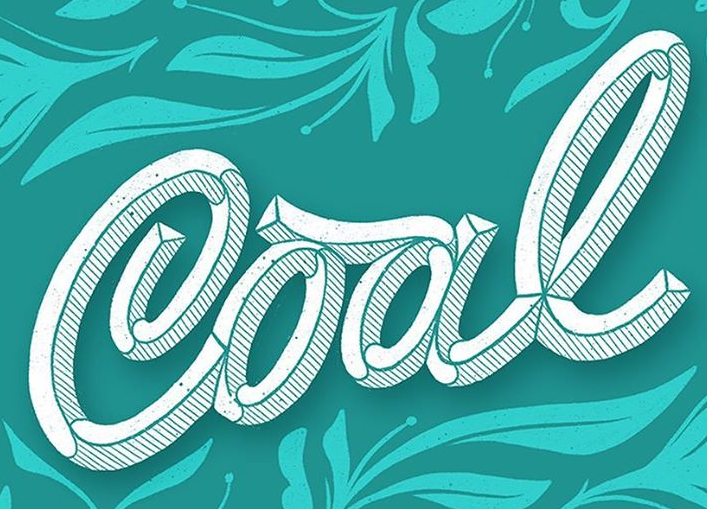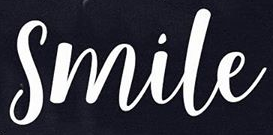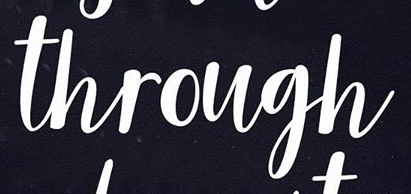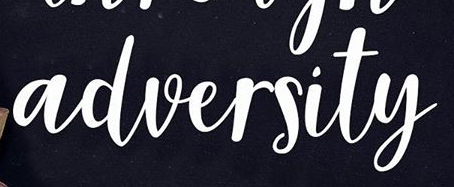Read the text from these images in sequence, separated by a semicolon. Cool; Smile; through; adversity 